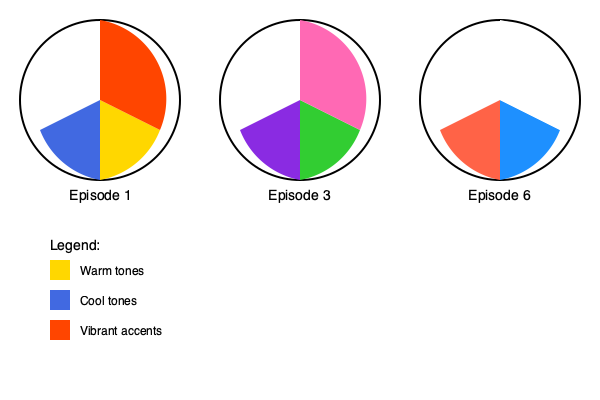Based on the color wheels representing the major scenes in FLCL episodes 1, 3, and 6, which episode shows the most significant shift towards cooler tones, and what might this suggest about the narrative progression? To answer this question, let's analyze the color wheels for each episode:

1. Episode 1:
   - Warm tones (gold): Dominant
   - Cool tones (royal blue): Secondary
   - Vibrant accent (orange-red): Tertiary

2. Episode 3:
   - Warm tones (lime green): Dominant
   - Cool tones (purple): Secondary
   - Vibrant accent (hot pink): Tertiary

3. Episode 6:
   - Cool tones (deep sky blue): Dominant
   - Warm tones (tomato red): Secondary
   - Neutral (white): Tertiary

Step-by-step analysis:
1. Compare the cool tone sections across episodes:
   - Episode 1: Small cool section (royal blue)
   - Episode 3: Slightly larger cool section (purple)
   - Episode 6: Largest cool section (deep sky blue)

2. Observe the shift in dominance:
   - Episodes 1 and 3: Warm tones are dominant
   - Episode 6: Cool tones become dominant

3. Consider the narrative implications:
   - The shift towards cooler tones in Episode 6 suggests a change in mood or atmosphere.
   - This could indicate a more serious or introspective tone as the series progresses.
   - The inclusion of white (neutral) in Episode 6 might suggest a sense of clarity or resolution.

4. Reflect on FLCL's storytelling:
   - FLCL is known for its complex narrative and character development.
   - The color shift likely mirrors the emotional journey of the protagonist, Naota.
   - The cooler palette in the final episode may represent maturity or understanding gained throughout the series.

Therefore, Episode 6 shows the most significant shift towards cooler tones, suggesting a more serious or reflective mood as the narrative reaches its conclusion.
Answer: Episode 6, indicating a more serious or reflective mood in the series' conclusion. 